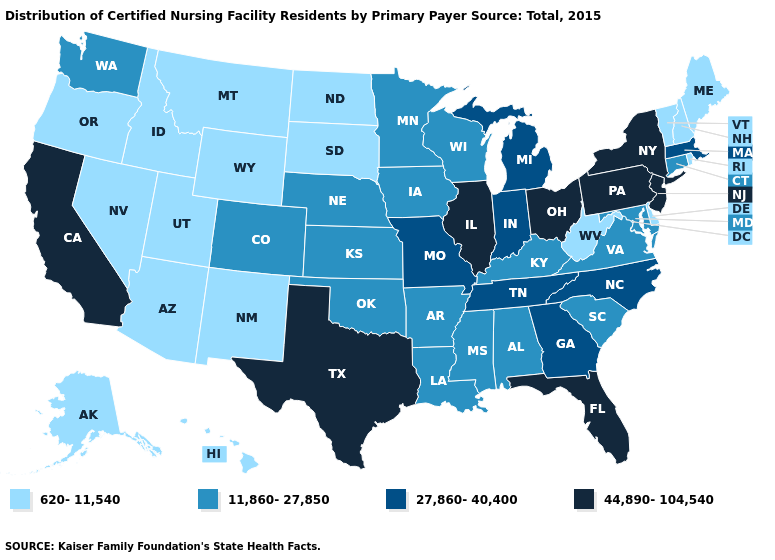Does Missouri have the highest value in the MidWest?
Answer briefly. No. Name the states that have a value in the range 27,860-40,400?
Answer briefly. Georgia, Indiana, Massachusetts, Michigan, Missouri, North Carolina, Tennessee. What is the lowest value in the USA?
Give a very brief answer. 620-11,540. Which states have the lowest value in the West?
Give a very brief answer. Alaska, Arizona, Hawaii, Idaho, Montana, Nevada, New Mexico, Oregon, Utah, Wyoming. Does the map have missing data?
Write a very short answer. No. Which states have the highest value in the USA?
Keep it brief. California, Florida, Illinois, New Jersey, New York, Ohio, Pennsylvania, Texas. What is the lowest value in the USA?
Keep it brief. 620-11,540. What is the highest value in the South ?
Quick response, please. 44,890-104,540. Name the states that have a value in the range 27,860-40,400?
Be succinct. Georgia, Indiana, Massachusetts, Michigan, Missouri, North Carolina, Tennessee. Name the states that have a value in the range 27,860-40,400?
Quick response, please. Georgia, Indiana, Massachusetts, Michigan, Missouri, North Carolina, Tennessee. What is the value of Georgia?
Be succinct. 27,860-40,400. What is the value of Oklahoma?
Give a very brief answer. 11,860-27,850. Does the first symbol in the legend represent the smallest category?
Give a very brief answer. Yes. What is the lowest value in the South?
Short answer required. 620-11,540. Name the states that have a value in the range 27,860-40,400?
Quick response, please. Georgia, Indiana, Massachusetts, Michigan, Missouri, North Carolina, Tennessee. 